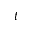<formula> <loc_0><loc_0><loc_500><loc_500>t</formula> 